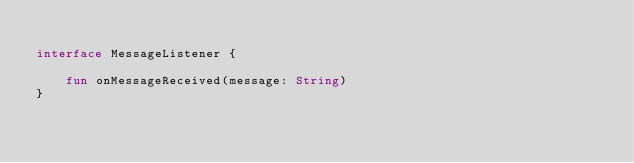<code> <loc_0><loc_0><loc_500><loc_500><_Kotlin_>
interface MessageListener {

    fun onMessageReceived(message: String)
}</code> 